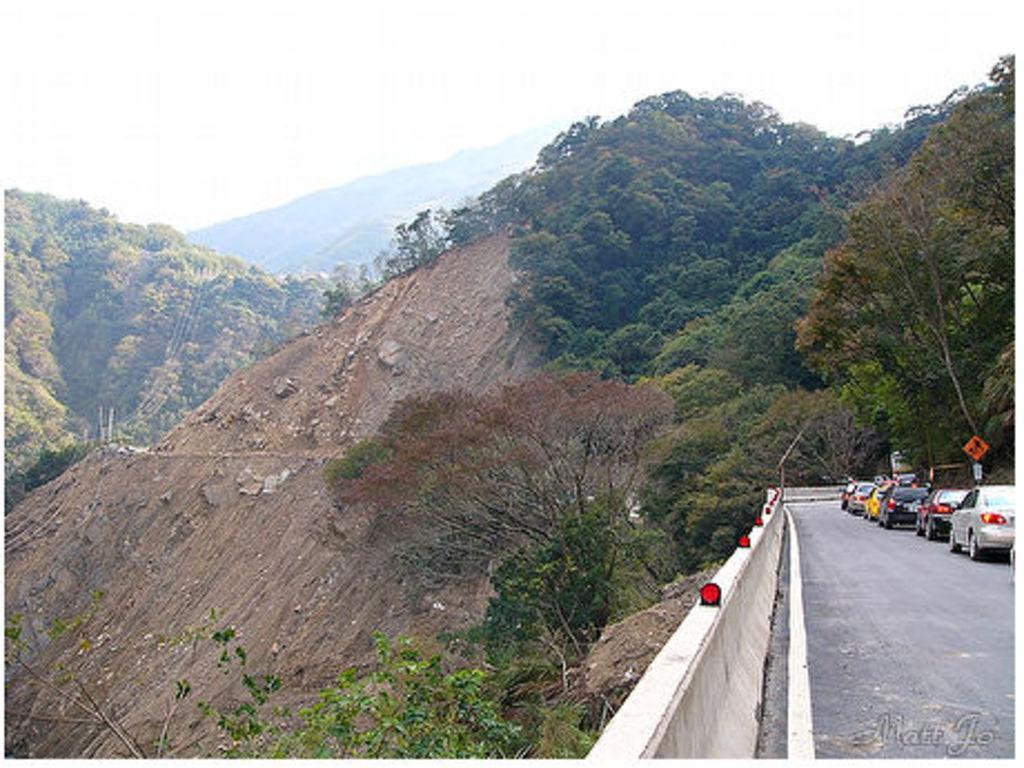Can you describe this image briefly? This is the picture of a mountain. On the right side of the image there are vehicles and there is a pole on the road. On the left side of the image there are trees on the mountains. At the top there is sky. 